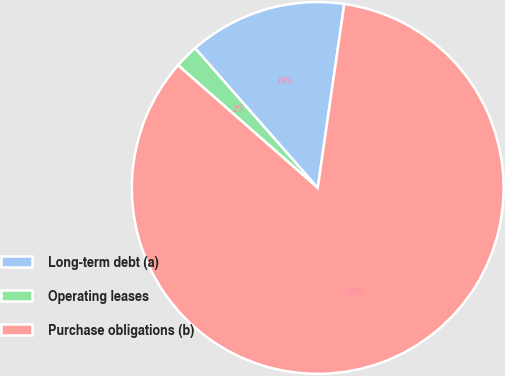<chart> <loc_0><loc_0><loc_500><loc_500><pie_chart><fcel>Long-term debt (a)<fcel>Operating leases<fcel>Purchase obligations (b)<nl><fcel>13.75%<fcel>2.06%<fcel>84.19%<nl></chart> 